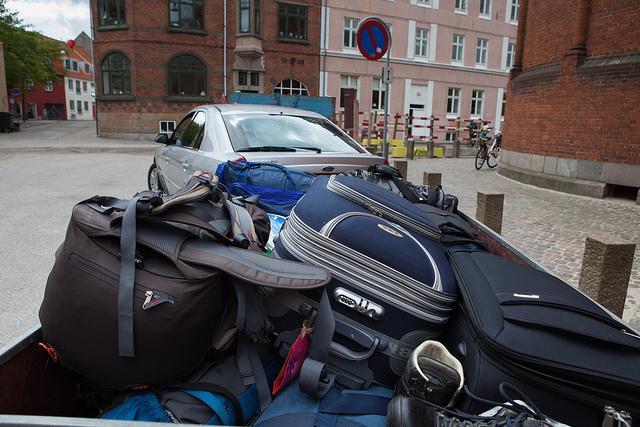What type window is the person who is photographing this luggage looking here?

Choices:
A) side
B) windshield
C) rear
D) front rear 